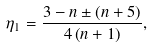<formula> <loc_0><loc_0><loc_500><loc_500>\eta _ { 1 } = \frac { 3 - n \pm \left ( n + 5 \right ) } { 4 \left ( n + 1 \right ) } ,</formula> 